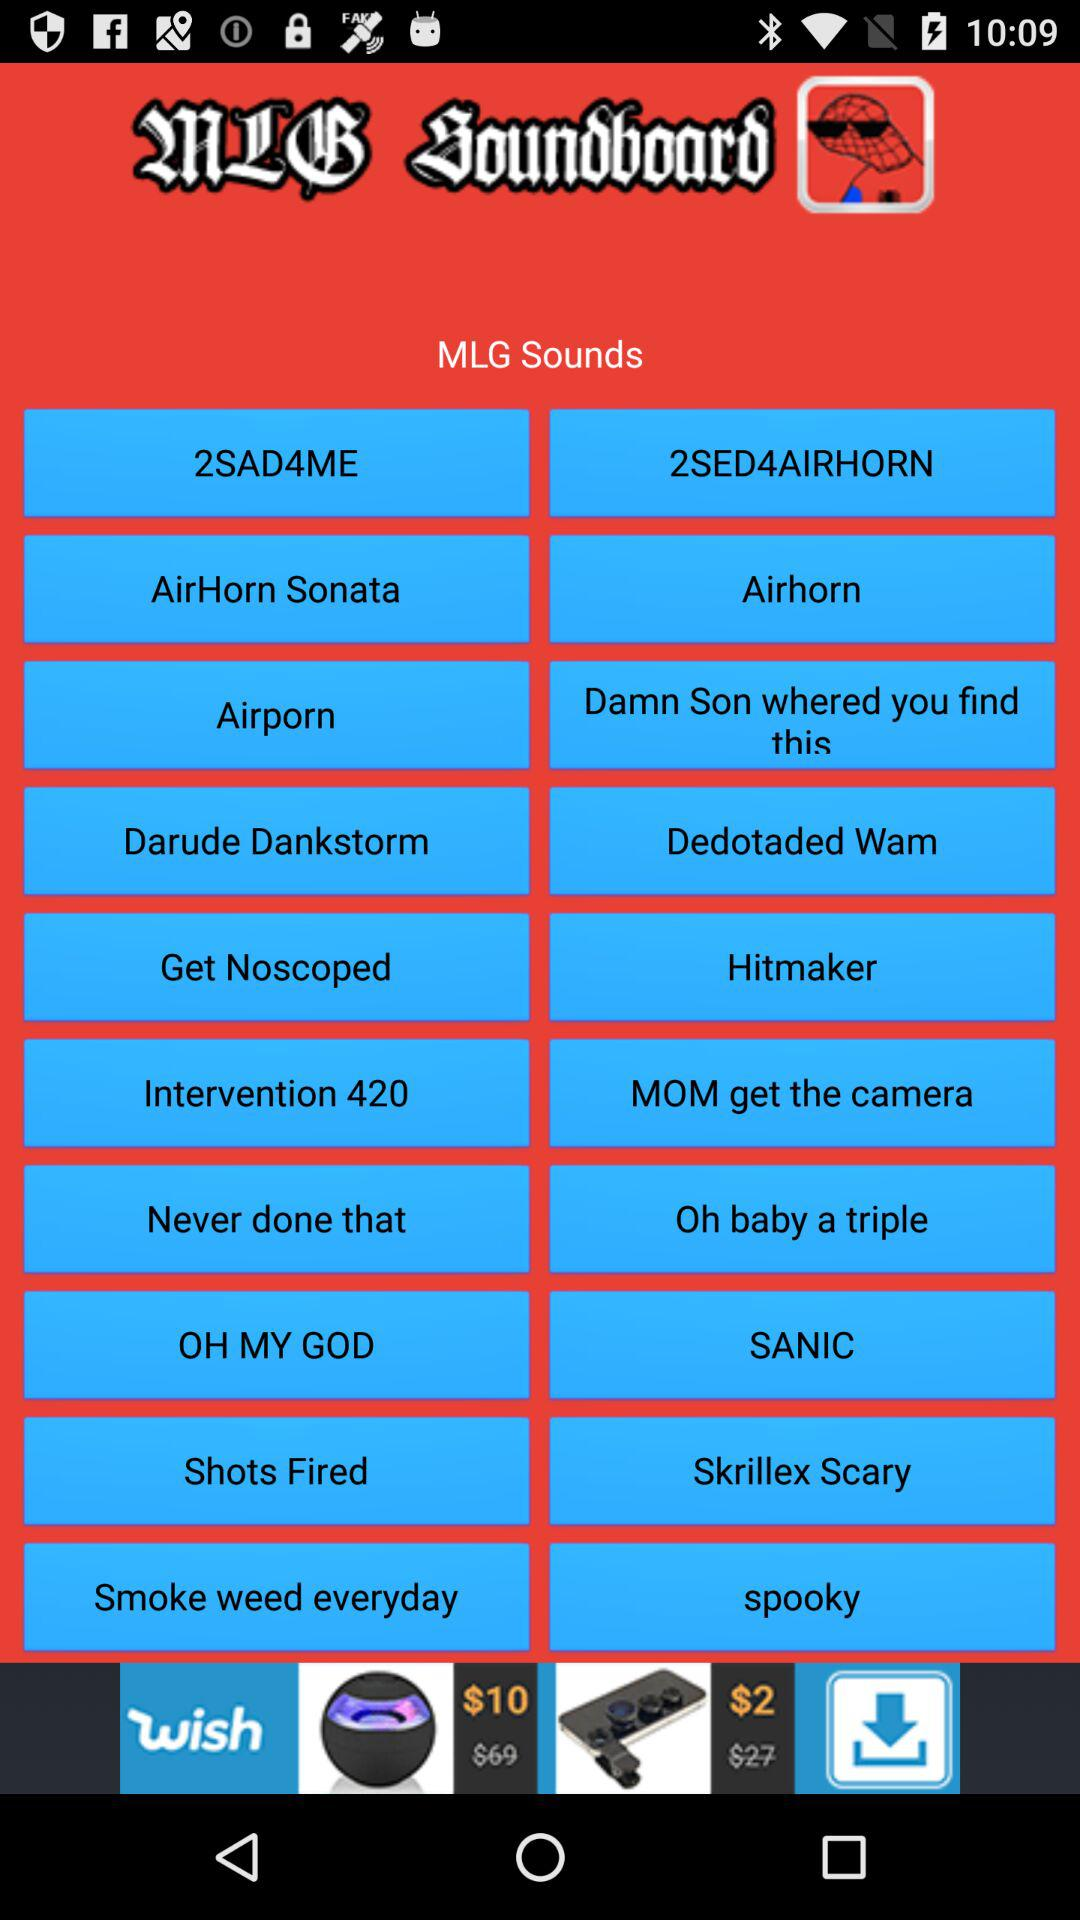What are the names of the MLG sounds? The names of the MLG sounds are "2SAD4ME", "2SED4AIRHORN", "AirHorn Sonata", "Airhorn", "Airporn", "Damn Son whered you find this", "Darude Dankstorm", "Dedotaded Wam", "Get Noscoped", "Hitmaker", "Intervention 420", "MOM get the camera", "Never done that", "Oh baby a triple", "OH MY GOD", "SANIC", "Shots Fired", "Skrillex Scary", "Smoke weed everyday" and "spooky". 